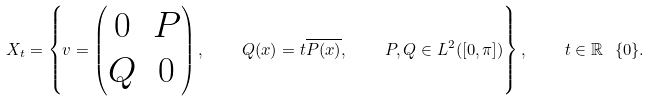<formula> <loc_0><loc_0><loc_500><loc_500>X _ { t } = \left \{ v = \begin{pmatrix} 0 & P \\ Q & 0 \end{pmatrix} , \quad Q ( x ) = t \overline { P ( x ) } , \quad P , Q \in L ^ { 2 } ( [ 0 , \pi ] ) \right \} , \quad t \in \mathbb { R } \ \{ 0 \} .</formula> 